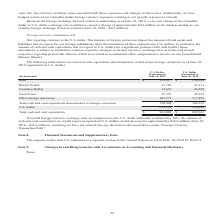According to Opentext Corporation's financial document, What is the reporting currency? According to the financial document, U.S. dollar. The relevant text states: "2019, a one cent change in the Canadian dollar to U.S. dollar exchange rate would have caused a change of approximately $0.6 million in the mark to market on our..." Also, What does the table show? cash and cash equivalents denominated in certain major foreign currencies as of June 30, 2019 (equivalent in U.S. dollar). The document states: "The following table shows our cash and cash equivalents denominated in certain major foreign currencies as of June 30, 2019 (equivalent in U.S. dollar..." Also, If overall foreign currency exchange rates in comparison to the U.S. dollar uniformly weakened by 10%, how much would the amount of cash and cash equivalents reported in equivalent U.S. dollars decrease by? approximately $32.9 million (June 30, 2018—$34.6 million), assuming we have not entered into any derivatives discussed above under "Foreign Currency Transaction Risk". The document states: "eport in equivalent U.S. dollars would decrease by approximately $32.9 million (June 30, 2018—$34.6 million), assuming we have not entered into any de..." Also, can you calculate: What is the average annual fiscal year Total cash and cash equivalents? To answer this question, I need to perform calculations using the financial data. The calculation is: (941,009+682,942)/2, which equals 811975.5 (in thousands). This is based on the information: "Total cash and cash equivalents $ 941,009 $ 682,942 Total cash and cash equivalents $ 941,009 $ 682,942..." The key data points involved are: 682,942, 941,009. Also, can you calculate: At June 30, 2019, what is the Euro U.S. dollar equivalent expressed as a percentage of Total cash and cash equivalents denominated in foreign currencies? Based on the calculation: 120,417/328,804, the result is 36.62 (percentage). This is based on the information: "U.S. Dollar Equivalent at June 30, 2018 Euro $ 120,417 $ 120,346 ash equivalents denominated in foreign currencies 328,804 346,258..." The key data points involved are: 120,417, 328,804. Also, can you calculate: What is the Total cash and cash equivalents denominated in foreign currencies expressed as a percentage of Total cash and cash equivalents at June 30, 2019? Based on the calculation: 328,804/941,009, the result is 34.94 (percentage). This is based on the information: "Total cash and cash equivalents $ 941,009 $ 682,942 ash equivalents denominated in foreign currencies 328,804 346,258..." The key data points involved are: 328,804, 941,009. 